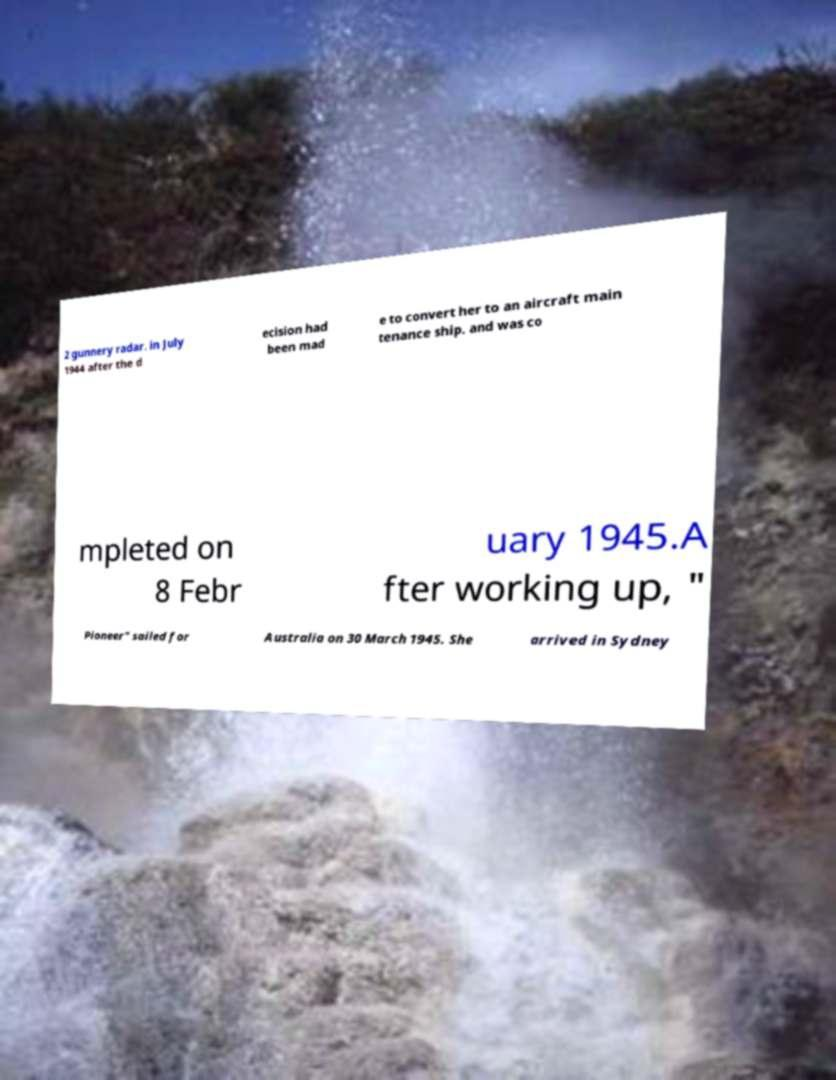Could you extract and type out the text from this image? 2 gunnery radar. in July 1944 after the d ecision had been mad e to convert her to an aircraft main tenance ship. and was co mpleted on 8 Febr uary 1945.A fter working up, " Pioneer" sailed for Australia on 30 March 1945. She arrived in Sydney 